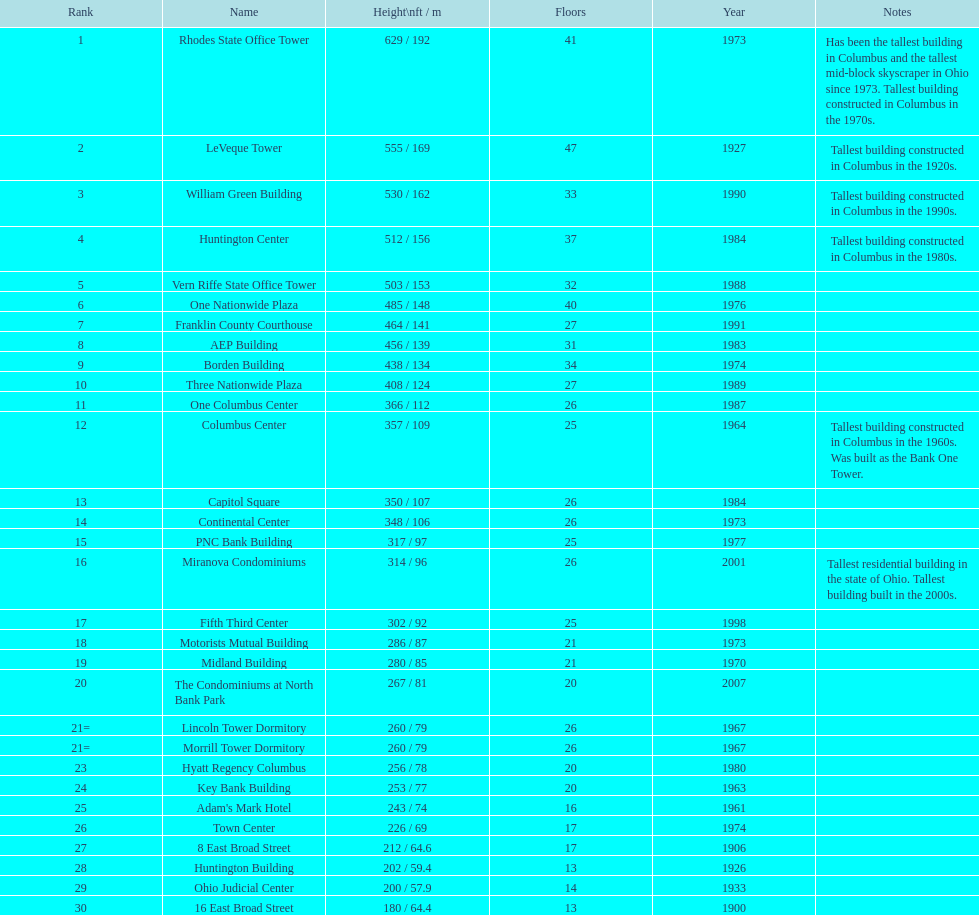Which is taller, the aep building or the one columbus center? AEP Building. 